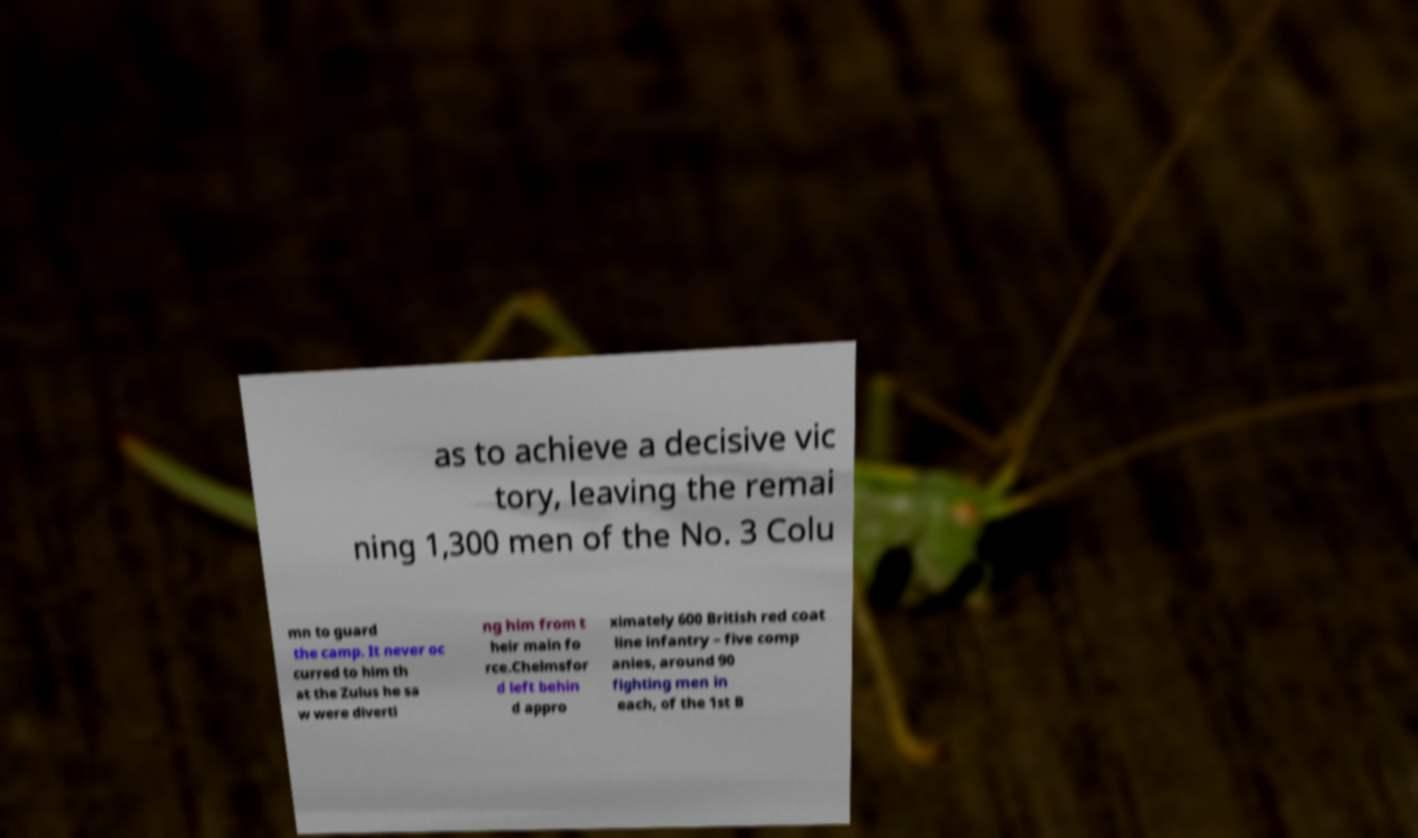Please identify and transcribe the text found in this image. as to achieve a decisive vic tory, leaving the remai ning 1,300 men of the No. 3 Colu mn to guard the camp. It never oc curred to him th at the Zulus he sa w were diverti ng him from t heir main fo rce.Chelmsfor d left behin d appro ximately 600 British red coat line infantry – five comp anies, around 90 fighting men in each, of the 1st B 